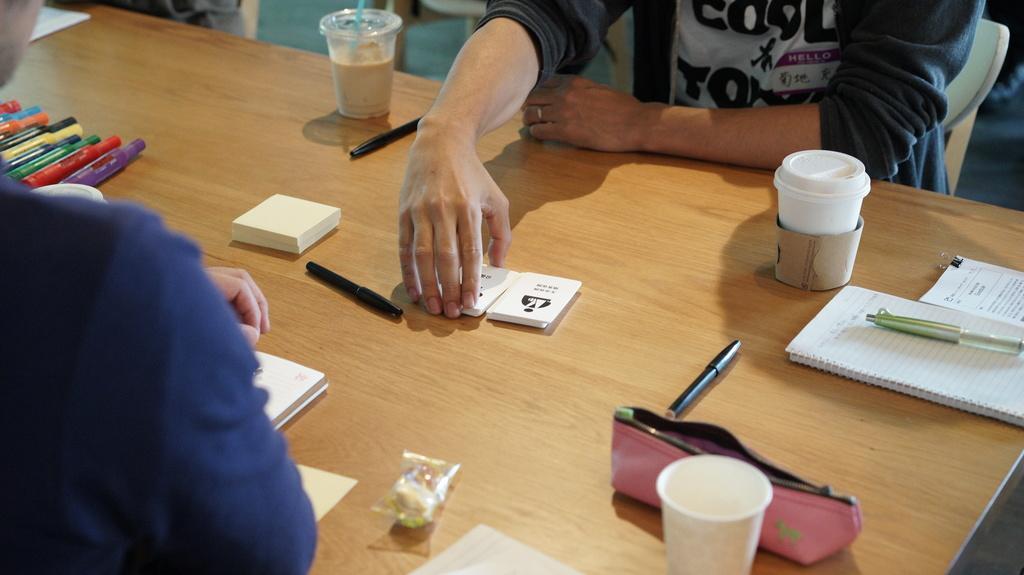Describe this image in one or two sentences. In this image on a table there are few cards,pen,markers,cup,pouch,book,packet. In the left one person is sitting. In the right to another person is sitting ,he is holding some cards. 